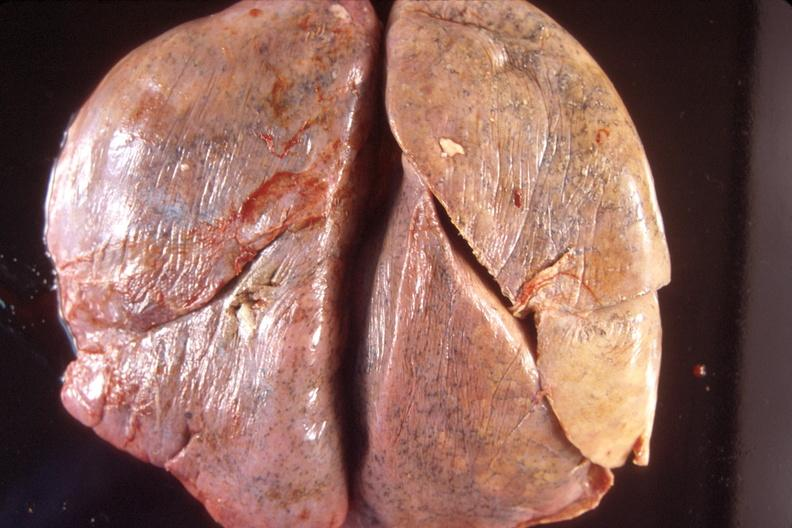does this image show normal lung?
Answer the question using a single word or phrase. Yes 